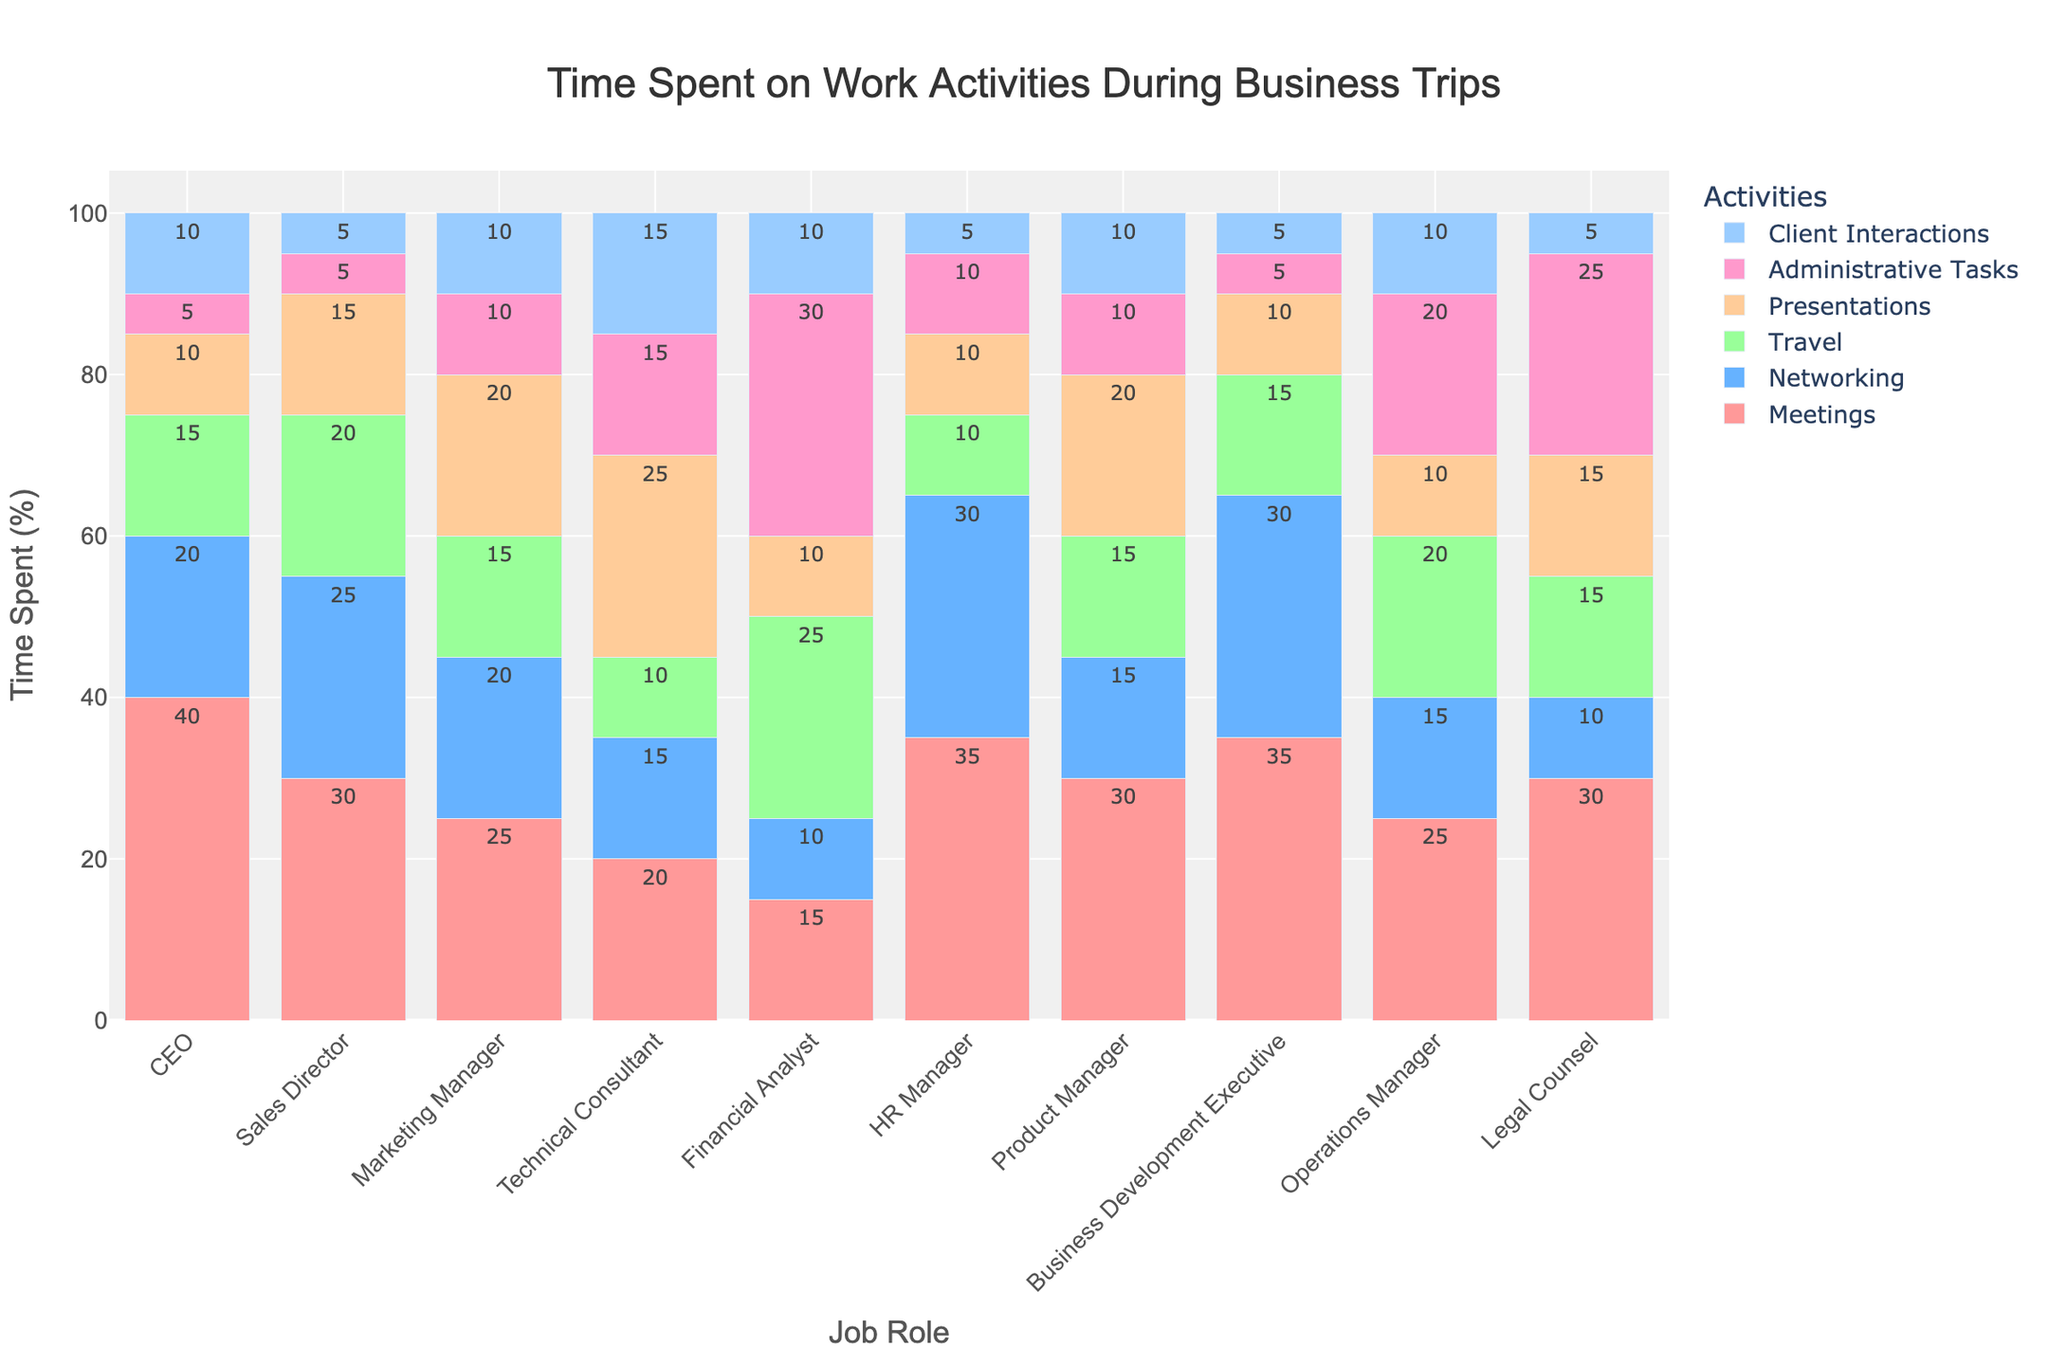Which job role spends the most time on meetings? By examining the heights of the bars corresponding to 'Meetings' for each job role, we can see that the 'CEO' has the tallest bar in this category.
Answer: CEO Which job role allocates the least amount of time to administrative tasks? By looking at the heights of the 'Administrative Tasks' bars, the 'Sales Director' and 'Business Development Executive' both have the smallest bar, indicating they spend the least time on administrative tasks.
Answer: Sales Director and Business Development Executive Compare the time spent on travel by a Financial Analyst and an Operations Manager. Who spends more time, and by how much? From the bar heights, the 'Financial Analyst' spends more time (25%) on travel compared to the 'Operations Manager' (20%). The difference is 25% - 20% = 5%.
Answer: Financial Analyst, 5% Which two activities take up the most and least percentage of time for a Technical Consultant? The bar heights reveal that 'Presentations' has the highest percentage (25%) and 'Travel' has the lowest percentage (10%) for a Technical Consultant.
Answer: Presentations, Travel How much more time does the HR Manager spend on networking compared to the Legal Counsel? The height of the 'Networking' bar for HR Manager is 30%, while for Legal Counsel, it is 10%. The difference is 30% - 10% = 20%.
Answer: 20% Which job role spends an equal amount of time on client interactions and networking? By examining the bars, the 'Marketing Manager' spends 10% on both client interactions and networking.
Answer: Marketing Manager What is the total time spent on presentations by the Product Manager and Marketing Manager combined? The 'Presentations' bar shows 20% for both the Product Manager and the Marketing Manager. The combined total is 20% + 20% = 40%.
Answer: 40% What is the average time spent on meetings across all job roles? Adding all percentages for 'Meetings' across job roles: 40 + 30 + 25 + 20 + 15 + 35 + 30 + 35 + 25 + 30 = 285%. There are 10 job roles, so the average is 285% / 10 = 28.5%.
Answer: 28.5% Which job role allocates the most time to client interactions? By examining the heights of the 'Client Interactions' bars, the 'Technical Consultant' spends the most time at 15%.
Answer: Technical Consultant 